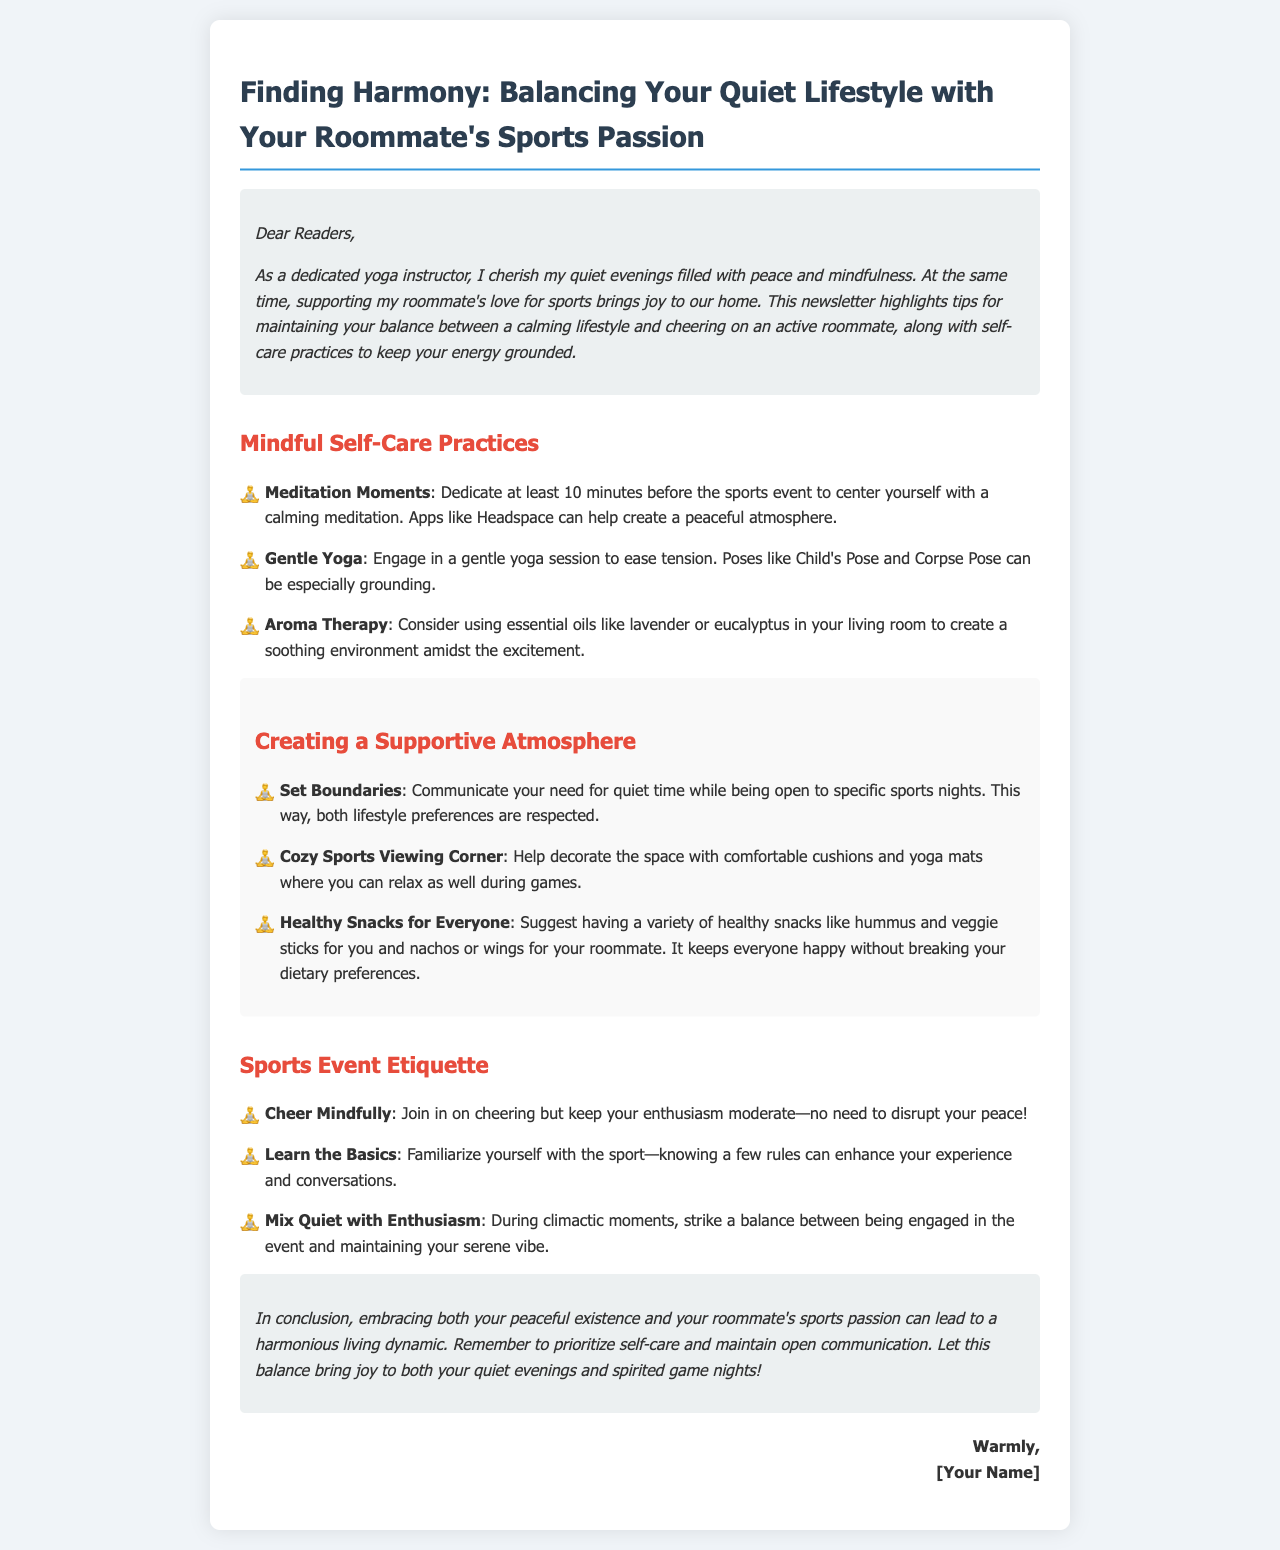What is the title of the newsletter? The title is the main heading of the document, which can be found at the top.
Answer: Finding Harmony: Balancing Your Quiet Lifestyle with Your Roommate's Sports Passion How many mindful self-care practices are mentioned? The number of listed practices in the section titled "Mindful Self-Care Practices" indicates the total count.
Answer: Three What essential oil is suggested for creating a soothing environment? The document specifies a particular oil in the "Aroma Therapy" practice.
Answer: Lavender What should you do before sports events according to the newsletter? The document suggests a specific practice to engage in prior to sports events.
Answer: Center yourself with a calming meditation What is advised to help decorate the sports viewing area? This detail relates to making the environment comfortable during games.
Answer: Comfortable cushions and yoga mats What does the newsletter recommend about cheering? The document provides guidance on how to approach cheering during sports events.
Answer: Cheer mindfully How should healthy snacks be chosen according to the newsletter? The advice regarding snack preparation reflects a balanced approach between preferences.
Answer: Variety of healthy snacks What is the newsletter focusing on overall? The primary theme is about balancing two different lifestyle preferences as mentioned in the introduction.
Answer: Harmony What is encouraged to prioritize for maintaining balance? The final recommendations stress the importance of a specific practice in the living dynamic.
Answer: Self-care 